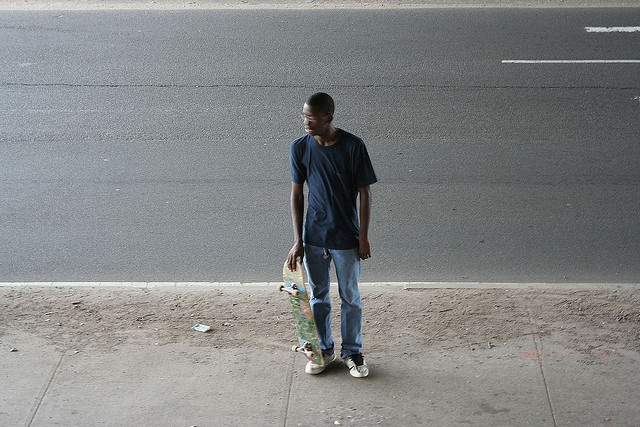Describe the objects in this image and their specific colors. I can see people in darkgray, black, gray, and navy tones and skateboard in darkgray, gray, and lightgray tones in this image. 